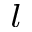Convert formula to latex. <formula><loc_0><loc_0><loc_500><loc_500>^ { l }</formula> 